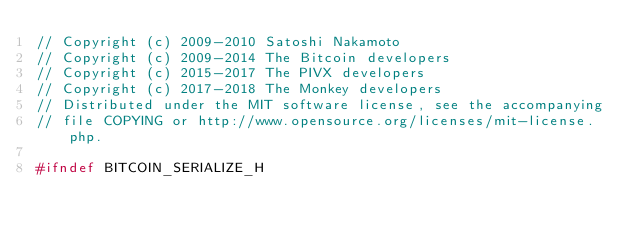<code> <loc_0><loc_0><loc_500><loc_500><_C_>// Copyright (c) 2009-2010 Satoshi Nakamoto
// Copyright (c) 2009-2014 The Bitcoin developers
// Copyright (c) 2015-2017 The PIVX developers
// Copyright (c) 2017-2018 The Monkey developers
// Distributed under the MIT software license, see the accompanying
// file COPYING or http://www.opensource.org/licenses/mit-license.php.

#ifndef BITCOIN_SERIALIZE_H</code> 